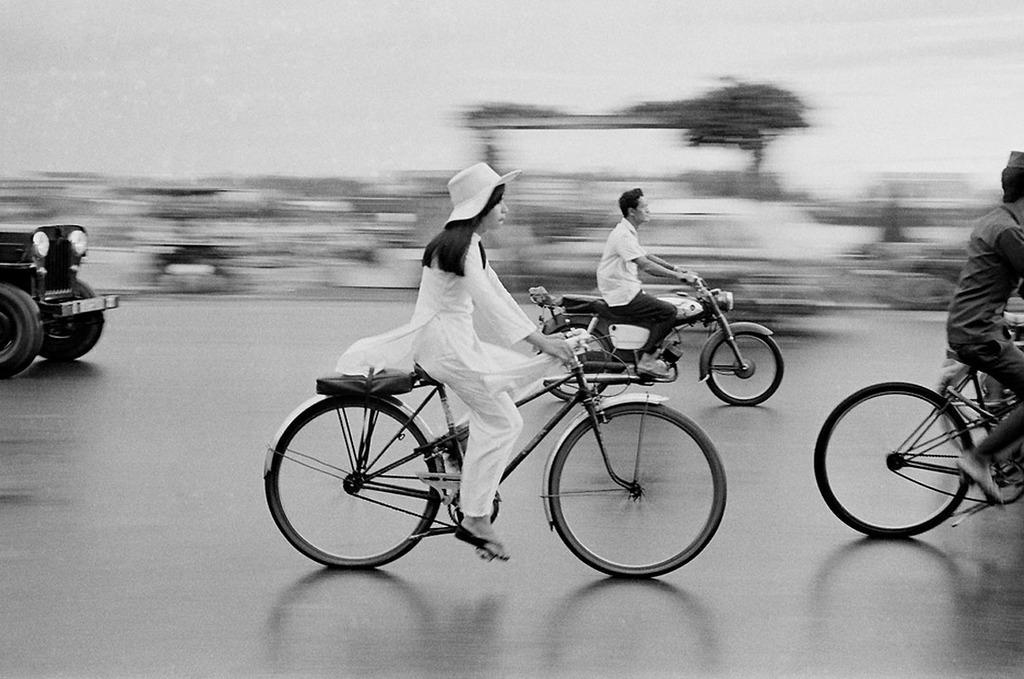Please provide a concise description of this image. This is a black and white picture. Background is very blurry. Here we can see persons riding bicycles on the road. Here we can see partial part of a vehicle. 